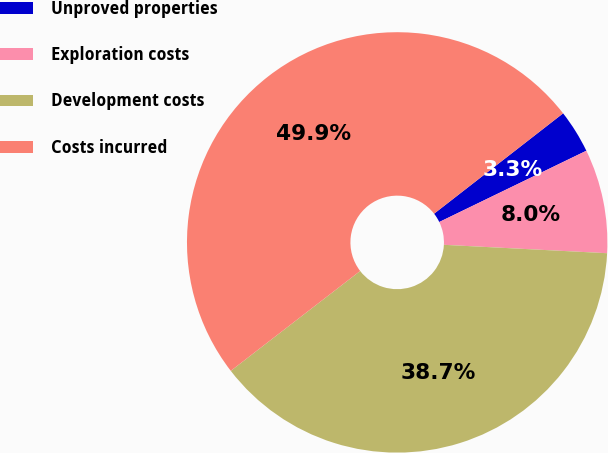Convert chart to OTSL. <chart><loc_0><loc_0><loc_500><loc_500><pie_chart><fcel>Unproved properties<fcel>Exploration costs<fcel>Development costs<fcel>Costs incurred<nl><fcel>3.34%<fcel>8.0%<fcel>38.72%<fcel>49.94%<nl></chart> 